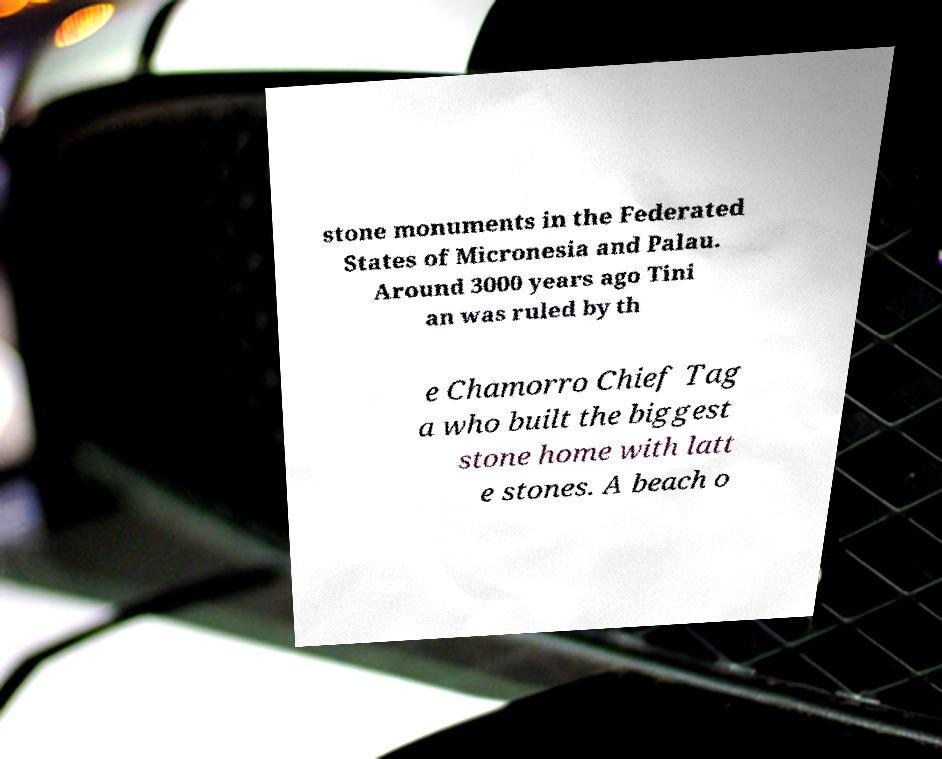Can you read and provide the text displayed in the image?This photo seems to have some interesting text. Can you extract and type it out for me? stone monuments in the Federated States of Micronesia and Palau. Around 3000 years ago Tini an was ruled by th e Chamorro Chief Tag a who built the biggest stone home with latt e stones. A beach o 